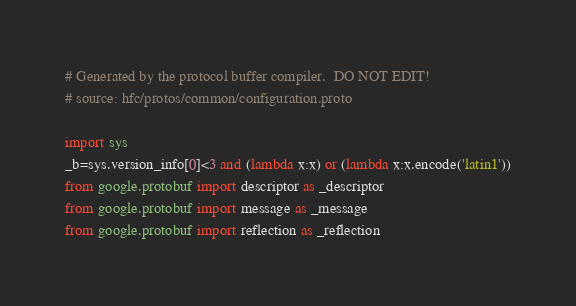<code> <loc_0><loc_0><loc_500><loc_500><_Python_># Generated by the protocol buffer compiler.  DO NOT EDIT!
# source: hfc/protos/common/configuration.proto

import sys
_b=sys.version_info[0]<3 and (lambda x:x) or (lambda x:x.encode('latin1'))
from google.protobuf import descriptor as _descriptor
from google.protobuf import message as _message
from google.protobuf import reflection as _reflection</code> 